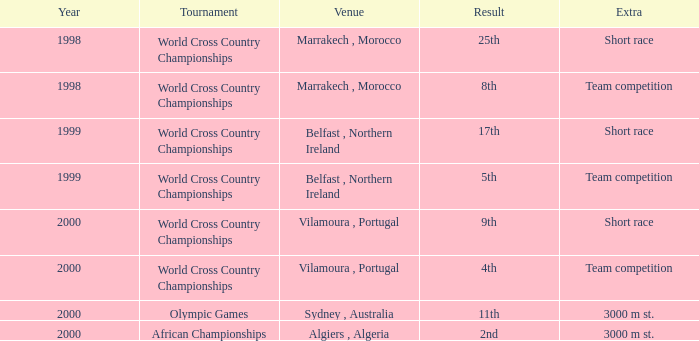Tell me the sum of year for 5th result 1999.0. 